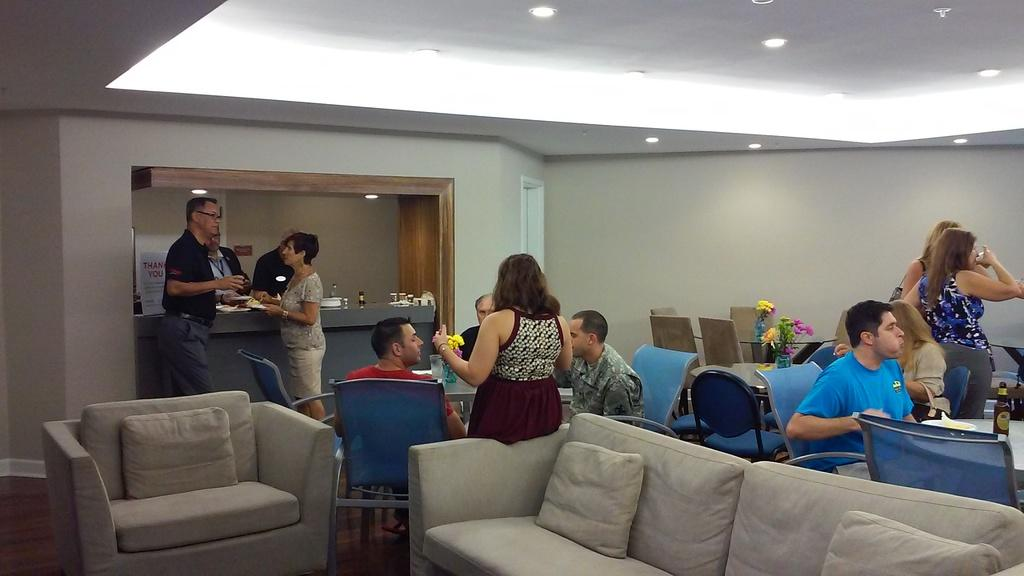What are the people in the image doing? The people in the image are sitting at a table. What can be found on the table with the people? There are eatables on the table. What type of furniture is visible in the image besides the table? There is an unoccupied sofa in the image. How many men with tails are sitting on the sofa in the image? There are: There are no men with tails present in the image; it features people sitting at a table and an unoccupied sofa. 